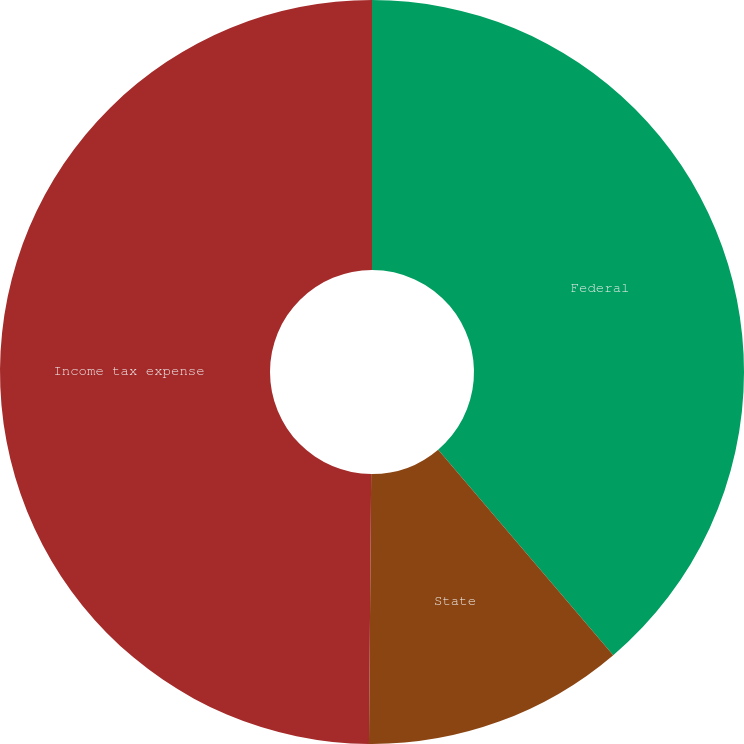Convert chart to OTSL. <chart><loc_0><loc_0><loc_500><loc_500><pie_chart><fcel>Federal<fcel>State<fcel>Income tax expense<nl><fcel>38.77%<fcel>11.36%<fcel>49.87%<nl></chart> 